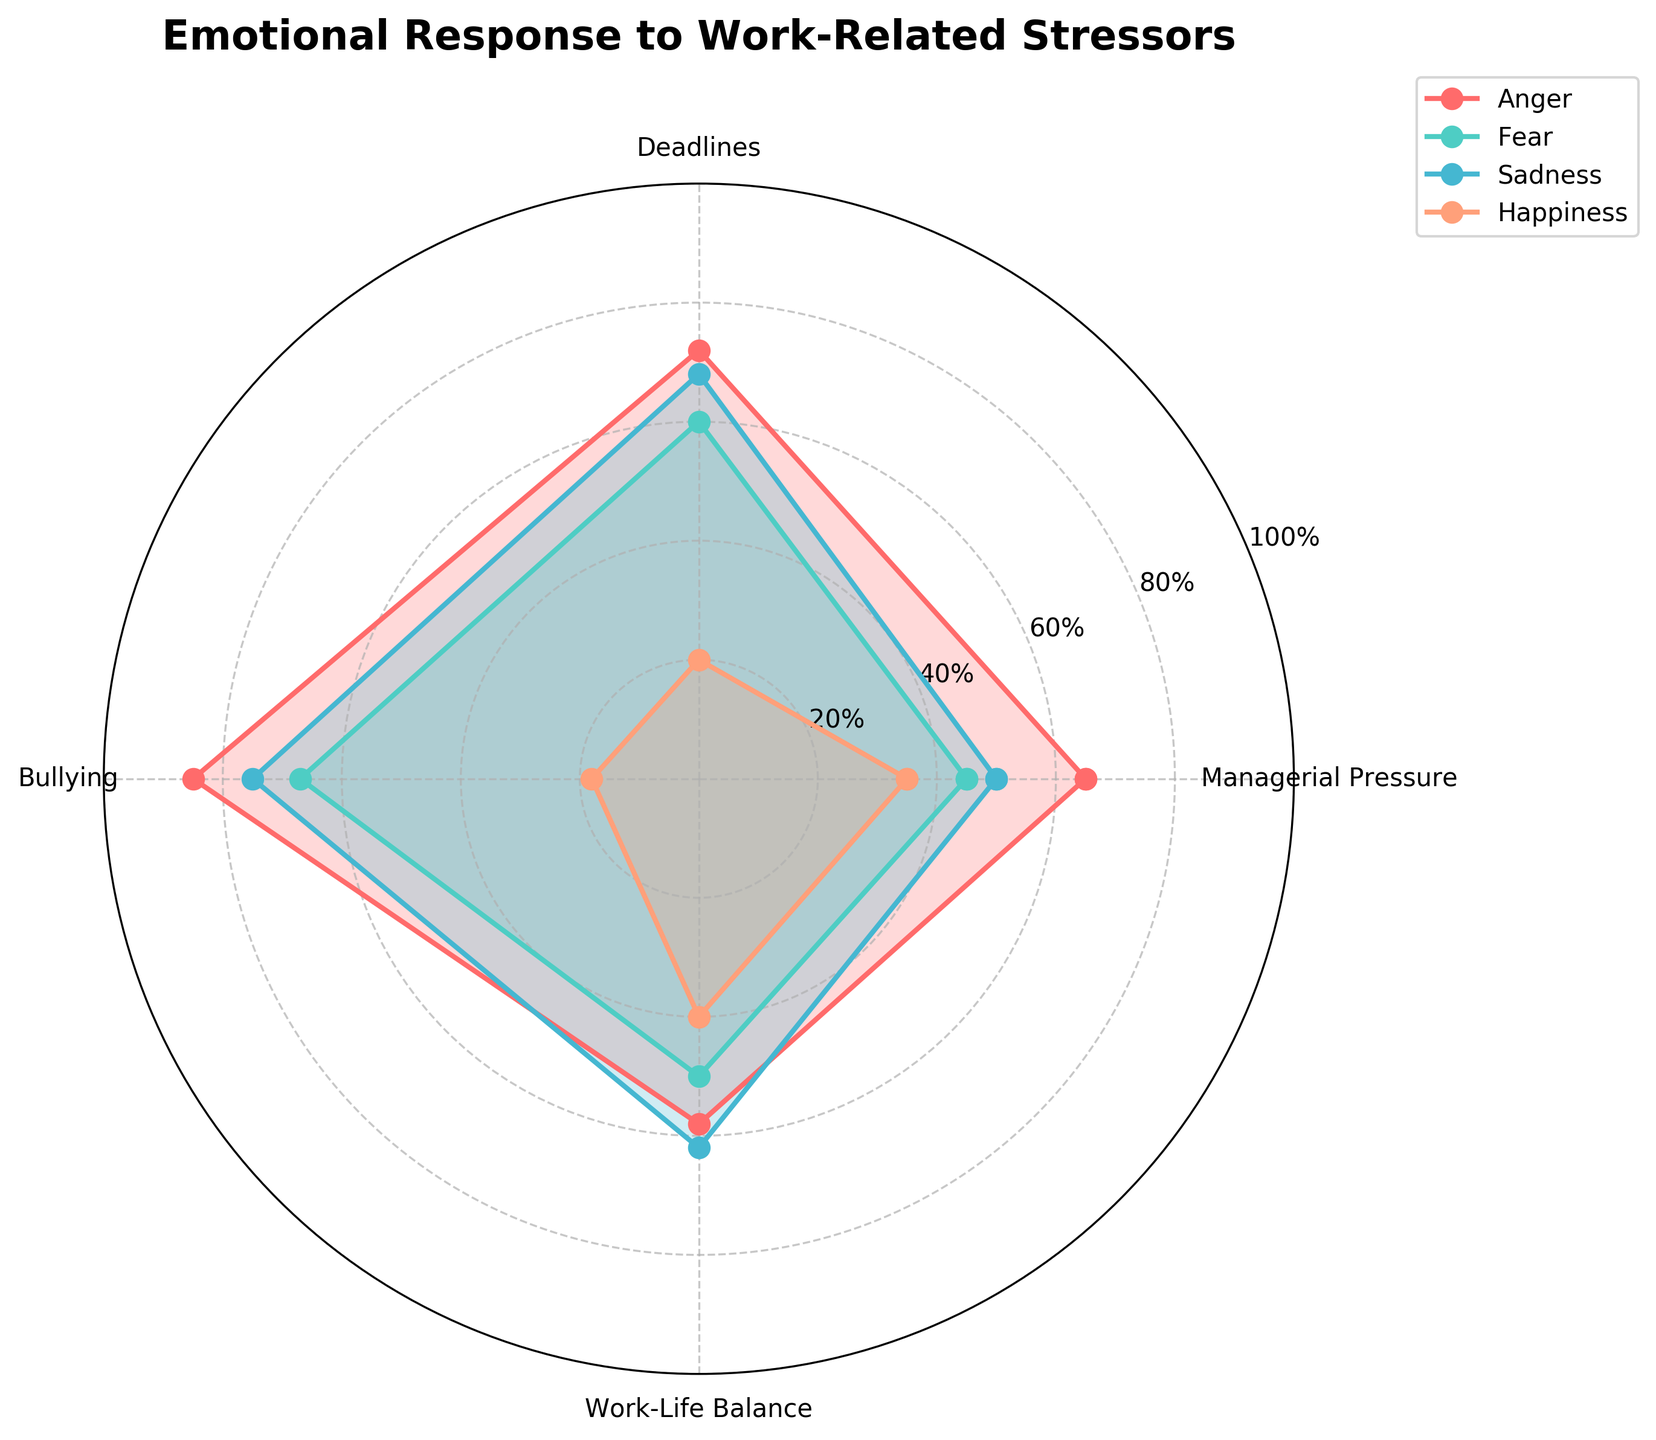What is the title of the chart? The title is typically positioned prominently at the top of the chart, directly specifying the subject of the visual representation. In this case, you can read the text at the top of the plot.
Answer: Emotional Response to Work-Related Stressors What emotions are represented in the chart? The names of the emotions are usually listed as labels or legends on the chart. In this radar chart, the emotions are represented by distinct colors and labels. We can see four emotions: Anger, Fear, Sadness, and Happiness.
Answer: Anger, Fear, Sadness, Happiness Which emotion has the highest response to bullying? By following the labels to the "Bullying" axis and comparing the peaks of each color-coded emotion, you can determine which one reaches the tallest on this axis. According to the radar chart, the emotion "Anger" peaks the highest in response to Bullying.
Answer: Anger On average, which emotion shows the lowest response across all stressors? To determine this, you need to calculate the average level of response for each emotion across all categories. The visual peaks for "Happiness" are consistently the lowest on all axes compared to other emotions. Adding all values (35 + 20 + 18 + 40 = 113), and it is visibly lower than others.
Answer: Happiness Which stressor evokes the least "Surprise"? To find this, you need to look at the section marked "Surprise" and compare the values under each stressor. The stator with the smallest value in this area will be the least evoking. The response to "Work-Life Balance" has the lowest plot point for "Surprise".
Answer: Work-Life Balance Between "Sadness" and "Happiness", which has a higher response to "Deadlines"? You compare the data points on the "Deadlines" axis for both "Sadness" and "Happiness". Looking at the radar chart, "Sadness" has a higher value compared to "Happiness" for "Deadlines".
Answer: Sadness What is the difference between the response of "Fear" and "Happiness" to "Managerial Pressure"? First, you locate the values for "Fear" and "Happiness" under "Managerial Pressure", which are 45 and 35 respectively. Subtracting these values gives the difference.
Answer: 10 Which emotion has a more balanced response across all stressors? A more balanced response implies less fluctuation across the axes. Observing the radar chart, "Fear" appears to have a more even distribution of data points with minimal variance compared to other emotions.
Answer: Fear 